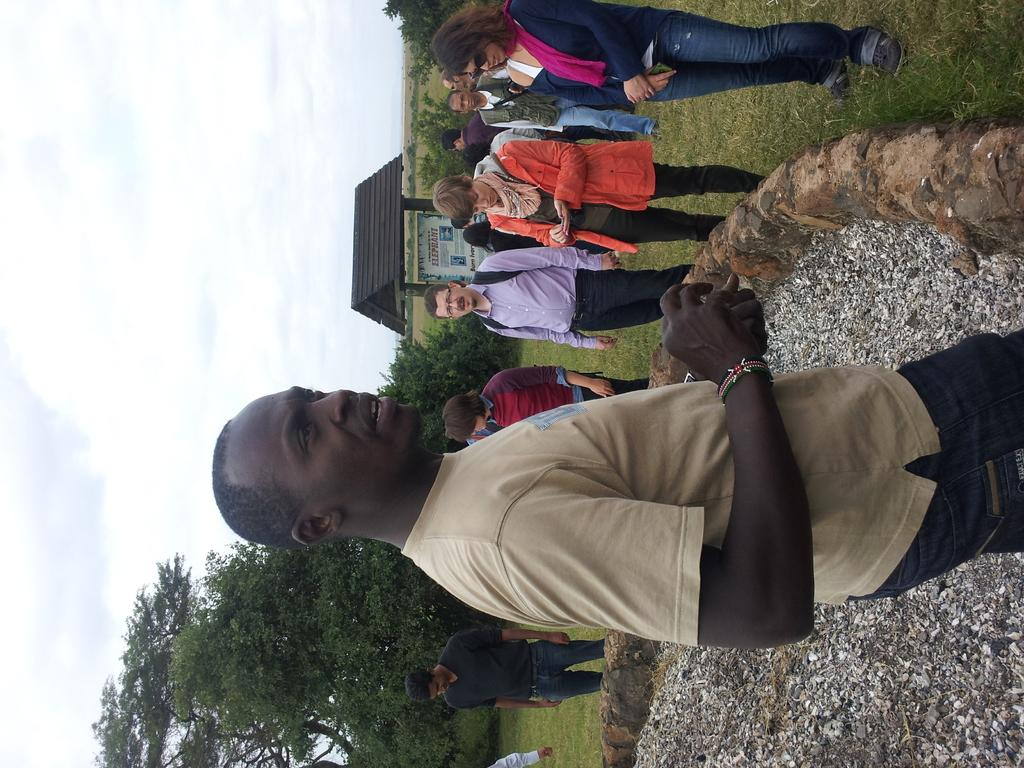What is happening in the image? There is a group of people standing in the image. What can be seen in the background of the image? There are trees and houses visible in the background of the image. How would you describe the weather in the image? The sky is cloudy in the image. What type of book is the carpenter reading in the image? There is no carpenter or book present in the image. What unit of measurement is being used to determine the height of the trees in the image? There is no indication of any unit of measurement being used to determine the height of the trees in the image. 